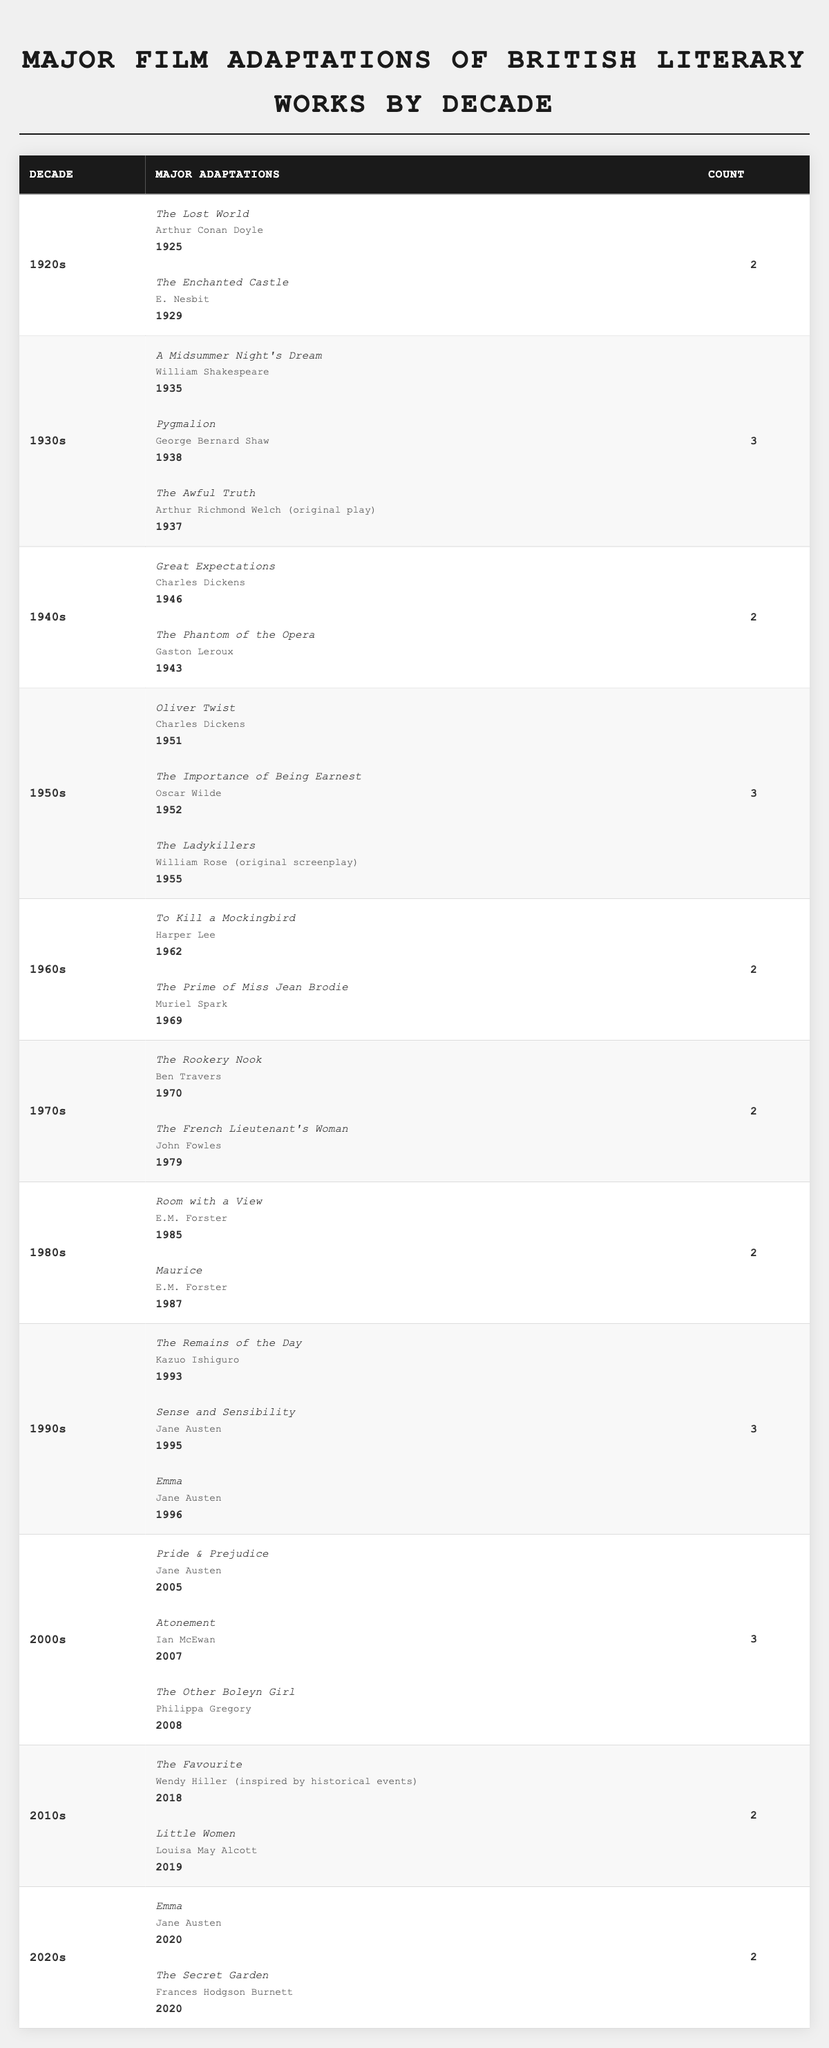What decade saw the highest number of major film adaptations? By reviewing the counts for each decade, the 1930s, 1950s, 1990s, and 2000s each have the highest count of 3. Therefore, these decades tie for the highest number.
Answer: 1930s, 1950s, 1990s, 2000s How many major film adaptations were there in the 1940s? The count for the 1940s is listed as 2 in the table.
Answer: 2 Which author had the most film adaptations in the 1990s? In the 1990s, Jane Austen's works, "Sense and Sensibility" and "Emma," were adapted into films, making her the author with the most adaptations in that decade.
Answer: Jane Austen How many major adaptations were released in the 2000s compared to the 1980s? In the 2000s, there were 3 adaptations, while in the 1980s there were only 2 adaptations. Thus, the difference is 3 - 2 = 1.
Answer: 1 Were there more adaptations in the 1960s or the 1970s? Both the 1960s and the 1970s had 2 adaptations each. Therefore, neither decade had more; they are equal.
Answer: They are equal What is the total number of film adaptations from the decades listed? To find the total, sum all the counts: 2 (1920s) + 3 (1930s) + 2 (1940s) + 3 (1950s) + 2 (1960s) + 2 (1970s) + 2 (1980s) + 3 (1990s) + 3 (2000s) + 2 (2010s) + 2 (2020s) = 26.
Answer: 26 In which decade did "A Midsummer Night's Dream" get adapted into a film? "A Midsummer Night's Dream" was adapted in the 1930s, specifically in 1935.
Answer: 1930s Which decade had the least major film adaptations? The 1960s, 1970s, and 1980s all had the least number of adaptations with a count of 2.
Answer: 1960s, 1970s, 1980s What is the average number of adaptations per decade from the 1920s to the 2020s? There are 11 decades from the 1920s to the 2020s with a total of 26 adaptations. The average is calculated as 26 / 11 = 2.36 (approximately).
Answer: 2.36 Did any authors have multiple adaptations in the same decade? Yes, in the 1990s, Jane Austen had "Sense and Sensibility" and "Emma" adapted, indicating multiple adaptations in that decade.
Answer: Yes 